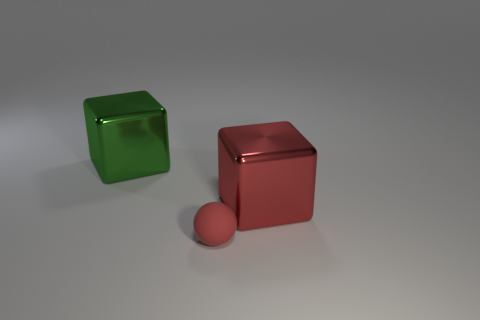Can you describe the colors in the image? Certainly, there are two primary colors represented in the objects within the image. We have a green transparent cube and a red, somewhat shiny cube alongside a red sphere. The background surface is in shades of gray. 